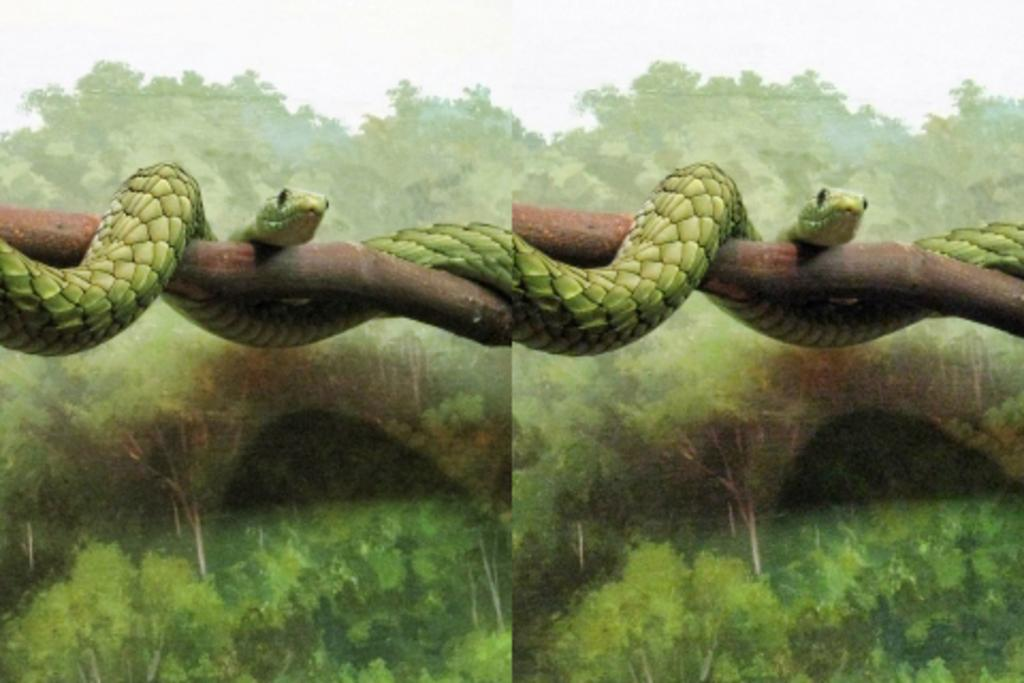What is the composition of the image? The image is a collage of two images. What can be seen in one of the images? There is a snake on a branch in the image. What is present in both images? There is a branch in the image. What type of copper material is used to create the dog in the image? There is no dog present in the image, and no copper material is mentioned or visible. 